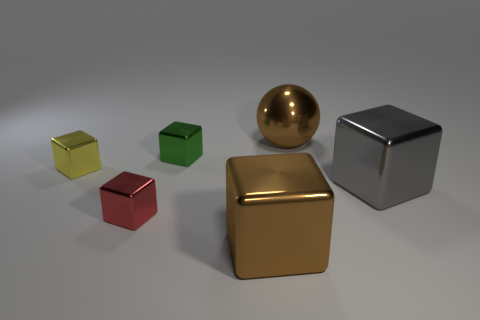What size is the metallic object that is the same color as the ball?
Provide a succinct answer. Large. Are there fewer large brown shiny blocks than blue rubber cylinders?
Provide a succinct answer. No. Do the tiny shiny object in front of the tiny yellow cube and the large ball have the same color?
Your response must be concise. No. What material is the brown object on the right side of the large thing that is in front of the large metallic cube that is right of the large sphere made of?
Your answer should be very brief. Metal. Are there any other large spheres that have the same color as the metal sphere?
Keep it short and to the point. No. Are there fewer large brown metal objects that are behind the small green object than tiny red blocks?
Provide a succinct answer. No. Do the brown metal object that is in front of the gray metallic cube and the tiny yellow cube have the same size?
Ensure brevity in your answer.  No. What number of small shiny cubes are to the left of the red metal cube and on the right side of the small yellow object?
Your answer should be compact. 0. There is a brown thing that is to the left of the large brown metal object behind the big brown block; what is its size?
Your answer should be compact. Large. Is the number of yellow objects behind the small yellow metallic cube less than the number of tiny red metallic objects behind the tiny red metallic object?
Ensure brevity in your answer.  No. 